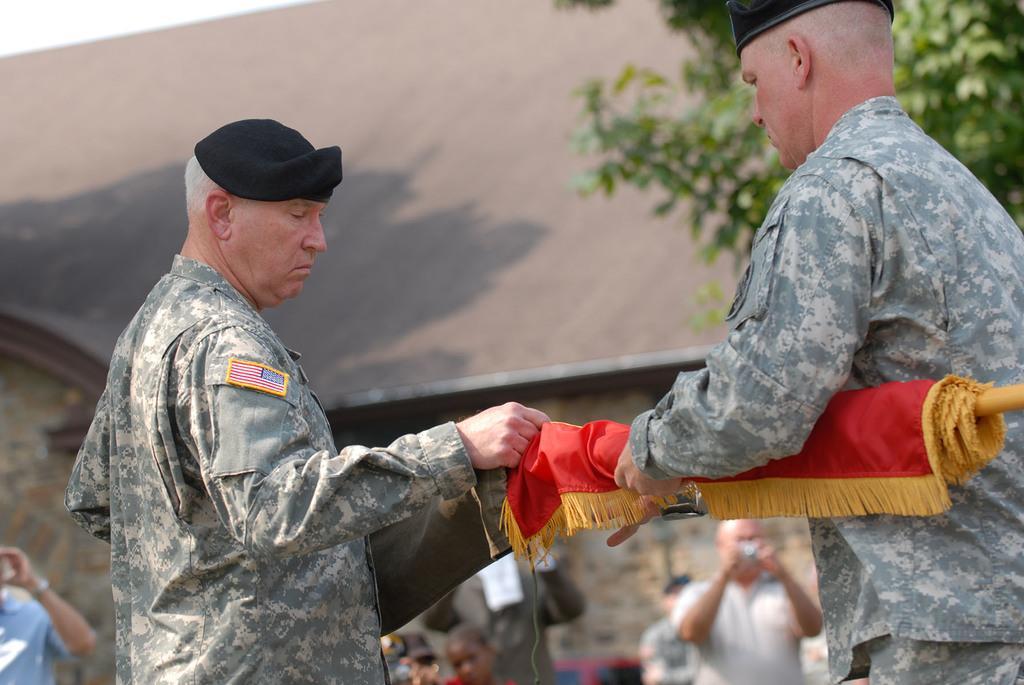Please provide a concise description of this image. This picture might be taken from outside of the city and it is sunny. In this image, on the right side, we can see a man standing and he is also holding something in his hands. On the left side, we can also see another person wearing a black color cap is standing. In the background, we can see group of people standing and few people are taking pictures, we can also see trees on the right side and a house. On top there is a sky. 